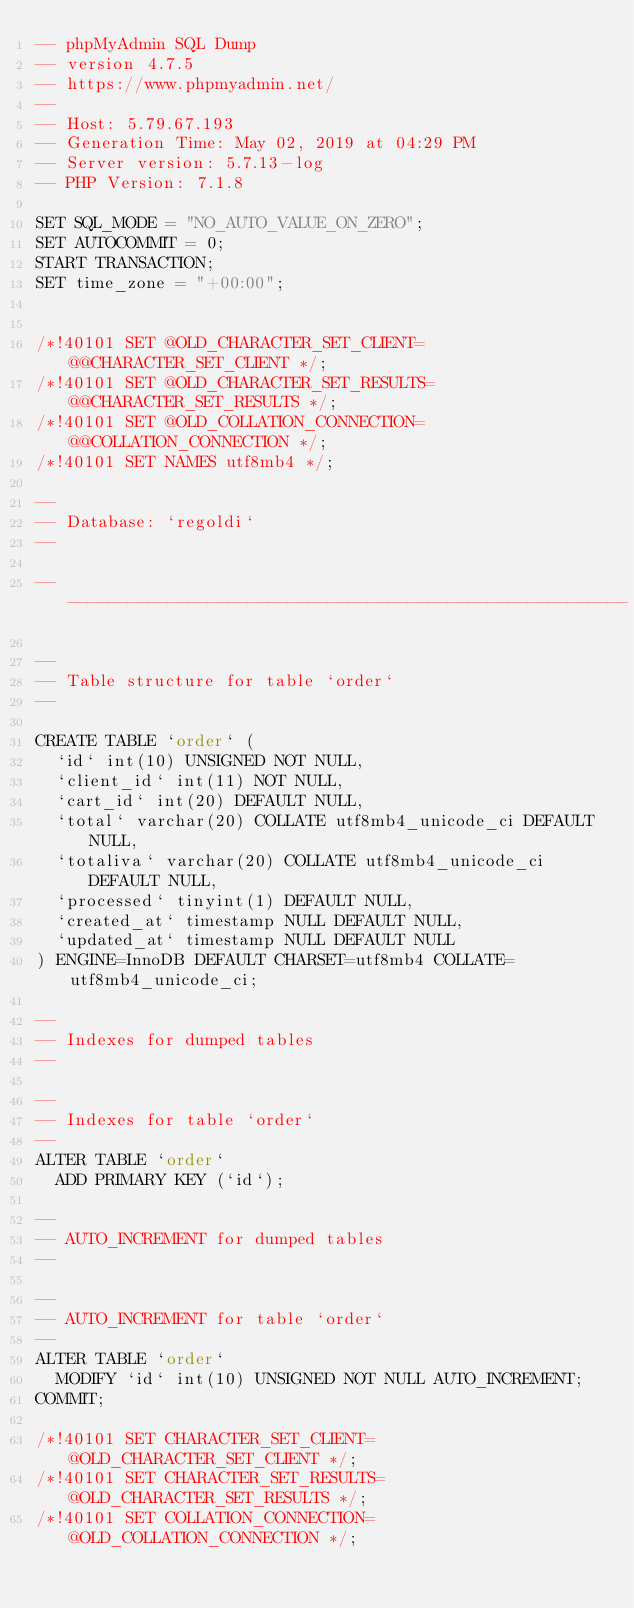Convert code to text. <code><loc_0><loc_0><loc_500><loc_500><_SQL_>-- phpMyAdmin SQL Dump
-- version 4.7.5
-- https://www.phpmyadmin.net/
--
-- Host: 5.79.67.193
-- Generation Time: May 02, 2019 at 04:29 PM
-- Server version: 5.7.13-log
-- PHP Version: 7.1.8

SET SQL_MODE = "NO_AUTO_VALUE_ON_ZERO";
SET AUTOCOMMIT = 0;
START TRANSACTION;
SET time_zone = "+00:00";


/*!40101 SET @OLD_CHARACTER_SET_CLIENT=@@CHARACTER_SET_CLIENT */;
/*!40101 SET @OLD_CHARACTER_SET_RESULTS=@@CHARACTER_SET_RESULTS */;
/*!40101 SET @OLD_COLLATION_CONNECTION=@@COLLATION_CONNECTION */;
/*!40101 SET NAMES utf8mb4 */;

--
-- Database: `regoldi`
--

-- --------------------------------------------------------

--
-- Table structure for table `order`
--

CREATE TABLE `order` (
  `id` int(10) UNSIGNED NOT NULL,
  `client_id` int(11) NOT NULL,
  `cart_id` int(20) DEFAULT NULL,
  `total` varchar(20) COLLATE utf8mb4_unicode_ci DEFAULT NULL,
  `totaliva` varchar(20) COLLATE utf8mb4_unicode_ci DEFAULT NULL,
  `processed` tinyint(1) DEFAULT NULL,
  `created_at` timestamp NULL DEFAULT NULL,
  `updated_at` timestamp NULL DEFAULT NULL
) ENGINE=InnoDB DEFAULT CHARSET=utf8mb4 COLLATE=utf8mb4_unicode_ci;

--
-- Indexes for dumped tables
--

--
-- Indexes for table `order`
--
ALTER TABLE `order`
  ADD PRIMARY KEY (`id`);

--
-- AUTO_INCREMENT for dumped tables
--

--
-- AUTO_INCREMENT for table `order`
--
ALTER TABLE `order`
  MODIFY `id` int(10) UNSIGNED NOT NULL AUTO_INCREMENT;
COMMIT;

/*!40101 SET CHARACTER_SET_CLIENT=@OLD_CHARACTER_SET_CLIENT */;
/*!40101 SET CHARACTER_SET_RESULTS=@OLD_CHARACTER_SET_RESULTS */;
/*!40101 SET COLLATION_CONNECTION=@OLD_COLLATION_CONNECTION */;
</code> 